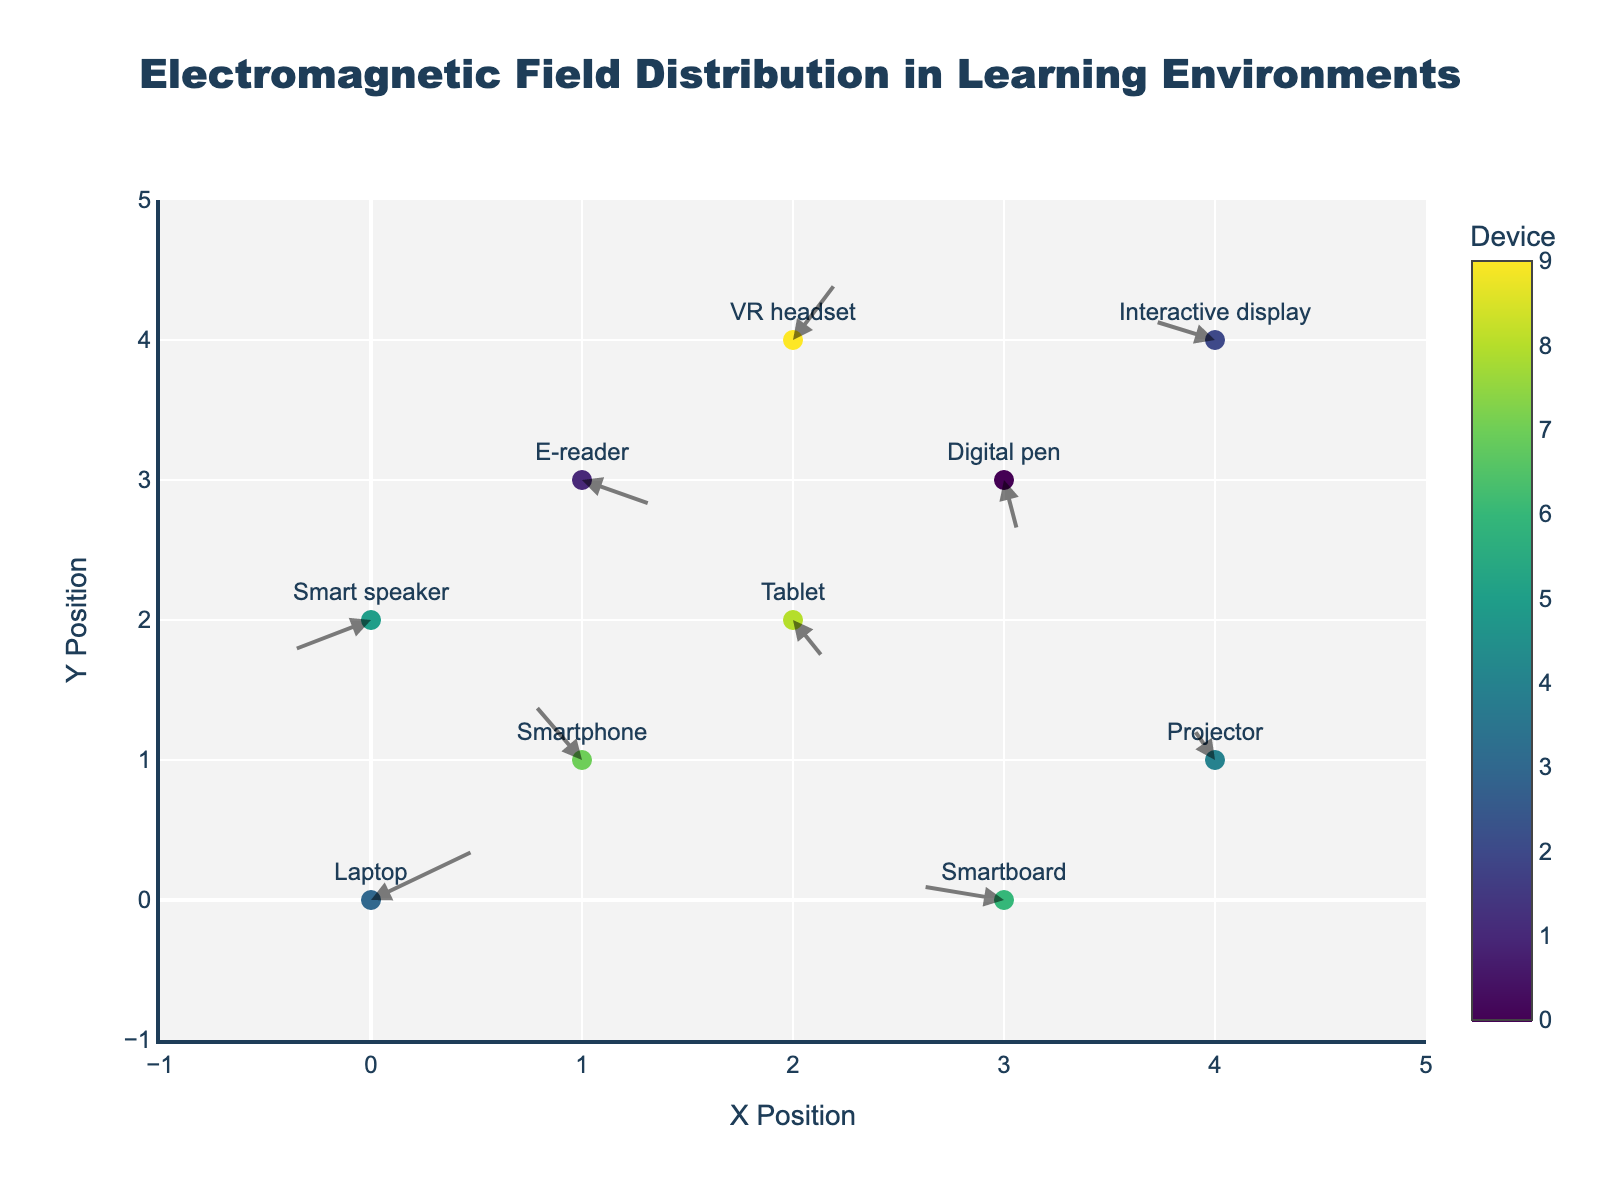What is the title of the plot? The title of the plot is displayed at the top of the figure, centered and prominently shown. It helps in understanding the main topic of the visual representation. The title reads "Electromagnetic Field Distribution in Learning Environments".
Answer: Electromagnetic Field Distribution in Learning Environments How many different electronic devices are represented in the plot? There are 10 data points in the plot, each representing a different electronic device as indicated by unique marker colors and labels. A quick count of the different device names or marker colors provides the answer.
Answer: 10 Which device has the highest x-position on the plot? To identify the device with the highest x-position, we look at the x-values of each data point and find the maximum value. The Projector and Interactive display both have the highest x-position of 4.
Answer: Projector and Interactive display What are the arrow directions for the VR headset and the Smartboard? The arrow direction is determined by the (u, v) components for each device. For the VR headset, the direction is (1.1, 2.2), and for the Smartboard, it is (-2.0, 0.5). This can be read from the corresponding positions of VR headset and Smartboard in the data table.
Answer: VR headset: (1.1, 2.2) and Smartboard: (-2.0, 0.5) Which device has the greatest magnitude of the electromagnetic field vector, and what is its value? The magnitude of the electromagnetic field vector is calculated using the formula √(u² + v²). We calculate this for each device, and the device with the highest value is the one we need. The VR headset has the greatest magnitude at √(1.1² + 2.2²) = 2.459.
Answer: VR headset: 2.459 Compare the vectors of the Laptop and Digital pen: Which one has a greater magnitude? To compare magnitudes, use the formula √(u² + v²) for both devices. For Laptop: √(2.5² + 1.8²) = 3.061. For Digital pen: √(0.4² + (-2.3)²) = 2.336. Thus, the Laptop has a greater magnitude.
Answer: Laptop What is the average u-component value of all devices in the plot? Sum all the u-component values and divide by the number of devices (10). (2.5 + -1.2 + 0.8 + -2.0 + 1.7 + -0.6 + 1.1 + -1.9 + 0.4 + -1.5) / 10 = -0.07.
Answer: -0.07 How does the direction of the electromagnetic field vector of the Tablet compare to that of the Smartphone? The Tablet's vector is (0.8, -1.5), and the Smartphone's vector is (-1.2, 2.1). The Tablet's u-component is positive while its v-component is negative, heading right and down. The Smartphone's u-component is negative while its v-component is positive, heading left and up. They have opposite directions.
Answer: Opposite directions Which device's electromagnetic field vector points directly to the left, and what are its components? A vector that points directly to the left will have a negative u-component and a zero v-component. By examining the data, no device has such characteristics. Thus, there is no device whose vector points directly to the left.
Answer: None 